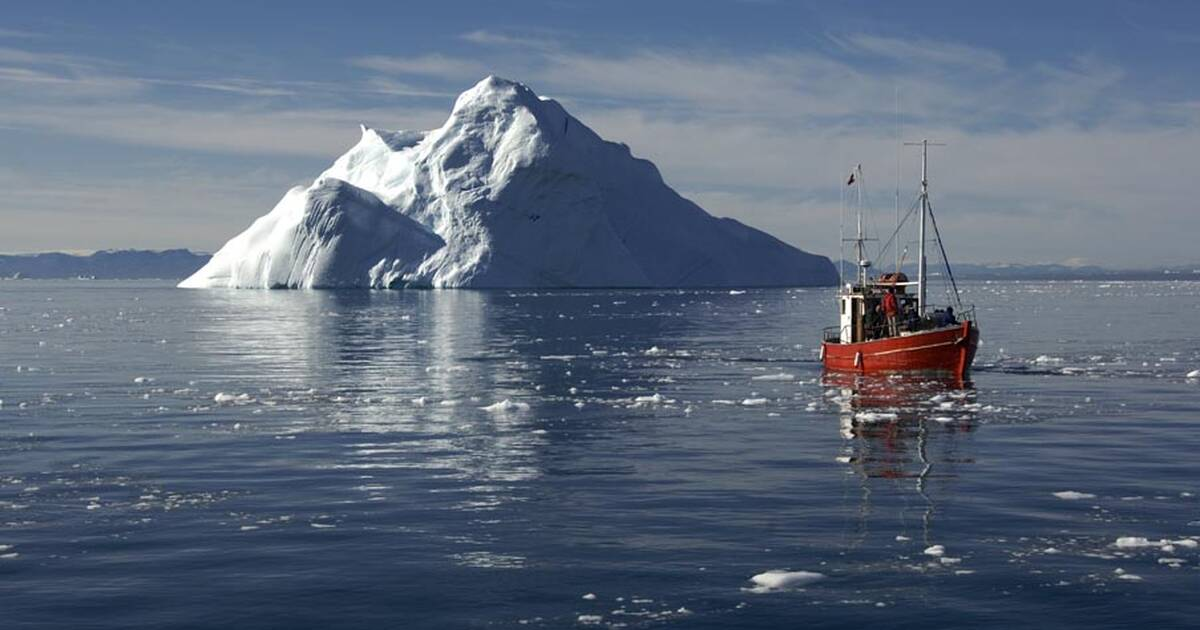Create a fictional story involving the fishing boat and the iceberg. Once upon a time, in the icy expanse of the Ilulissat Icefjord, a small red fishing boat named ‘Aurora’ set out on a journey unlike any other. Captain Lars, a seasoned sailor with a fondness for the stories his grandfather used to tell, was at the helm. His ambition was not just to fish but to discover the legendary ‘Heart of the Icefjord’—a crystal believed to grant eternal protection to whomever possessed it.

One serene morning, as Aurora gently sliced through the frigid waters, Captain Lars noticed something unusual about the massive iceberg ahead. The iceberg seemed different, with shimmering hues that danced across its surface, reflecting the light in an almost magical way. Convinced it was a sign, Lars ordered his crew to steer closer.

As they approached, a hidden cave at the base of the iceberg came into view, partially submerged and glistening with icicles. Lars, with a mix of trepidation and excitement, decided to explore the cave. Equipping himself with only a headlamp and a thick rope, he descended into the icy depths. Inside, the cave walls sparkled with frozen stalactites and crystals. It was there, deep within the heart of the iceberg, that he found it—the ‘Heart of the Icefjord’—a magnificent, clear crystal pulsating with a gentle blue light.

Triumphant, Captain Lars emerged from the cave. To his crew’s astonishment, he held the legendary crystal, shimmering like the stars. From that day forward, Aurora sailed under the protection of the Heart of the Icefjord, becoming a symbol of hope and resilience among the local fishing community. And so, the legend of the Heart's magic—and the bravery of Captain Lars—were immortalized in the tales told by sailors for generations to come. 